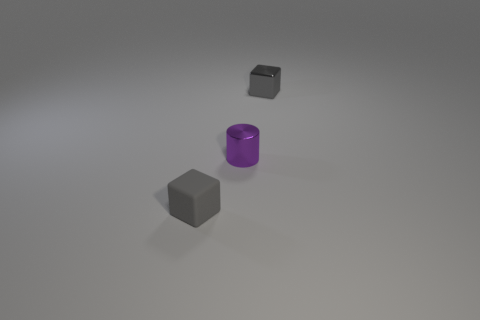What number of other cylinders have the same size as the purple cylinder?
Offer a terse response. 0. There is a shiny thing on the right side of the small metallic cylinder; does it have the same size as the gray cube that is in front of the tiny gray metal cube?
Offer a very short reply. Yes. There is a small shiny object in front of the tiny shiny block; what shape is it?
Give a very brief answer. Cylinder. What material is the small gray object that is to the left of the gray thing that is behind the tiny purple metal cylinder made of?
Provide a succinct answer. Rubber. Is there another block of the same color as the tiny rubber cube?
Offer a very short reply. Yes. There is a metallic cylinder; is its size the same as the gray thing that is in front of the tiny purple object?
Offer a very short reply. Yes. What number of cubes are to the right of the small gray block to the right of the block in front of the purple metallic object?
Your answer should be compact. 0. There is a small purple metal cylinder; what number of small blocks are behind it?
Provide a succinct answer. 1. The metal object on the right side of the tiny purple object that is behind the gray matte thing is what color?
Provide a short and direct response. Gray. How many other things are the same material as the small cylinder?
Provide a succinct answer. 1. 